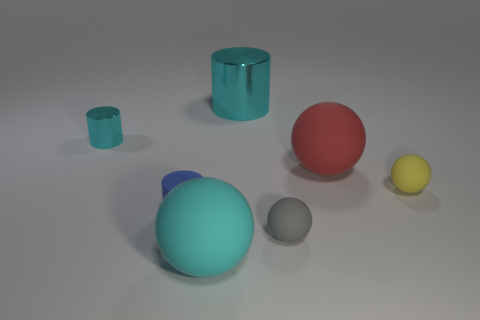Can you tell me the colors of the objects from the left to the right? Sure! From the left to the right, the objects are turquoise, blue, red, gray, and yellow. 